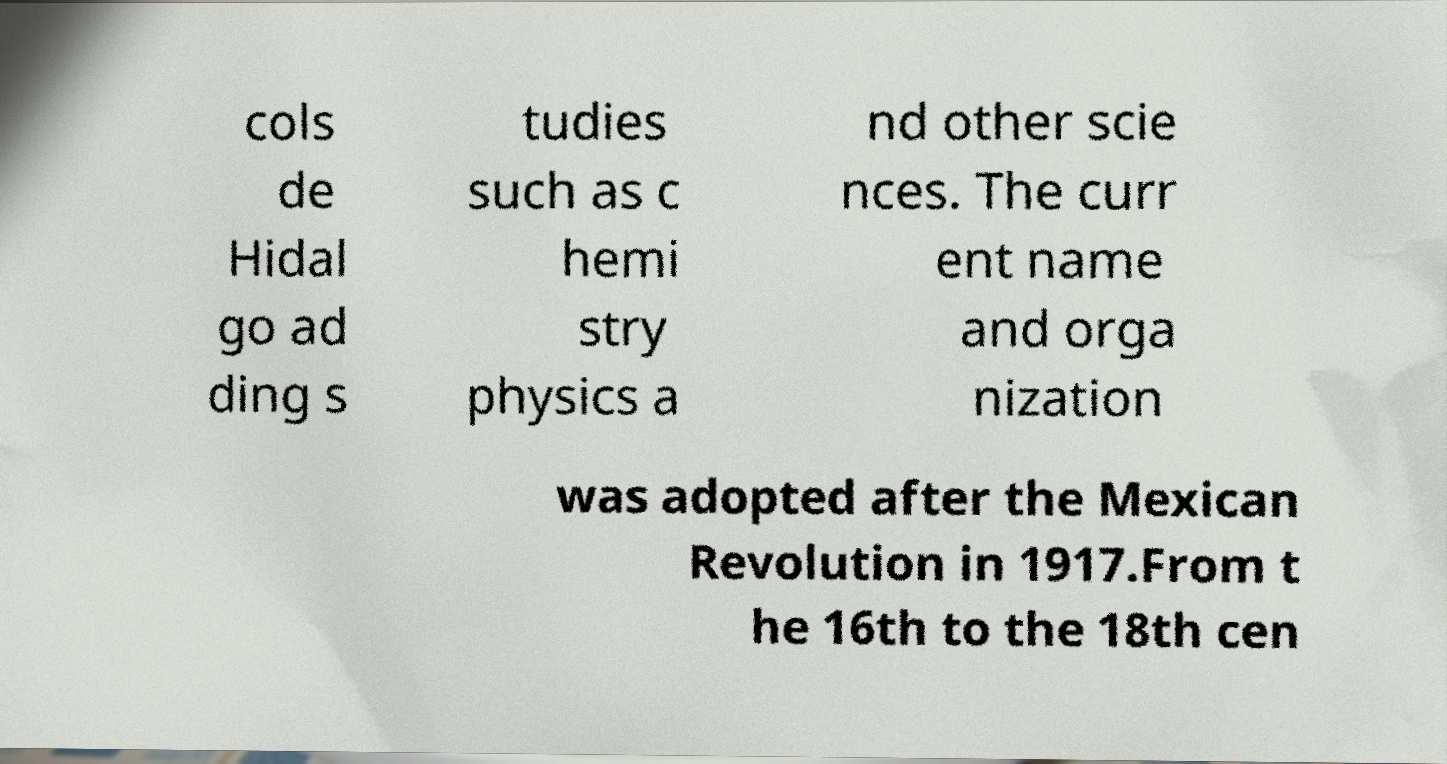Could you extract and type out the text from this image? cols de Hidal go ad ding s tudies such as c hemi stry physics a nd other scie nces. The curr ent name and orga nization was adopted after the Mexican Revolution in 1917.From t he 16th to the 18th cen 